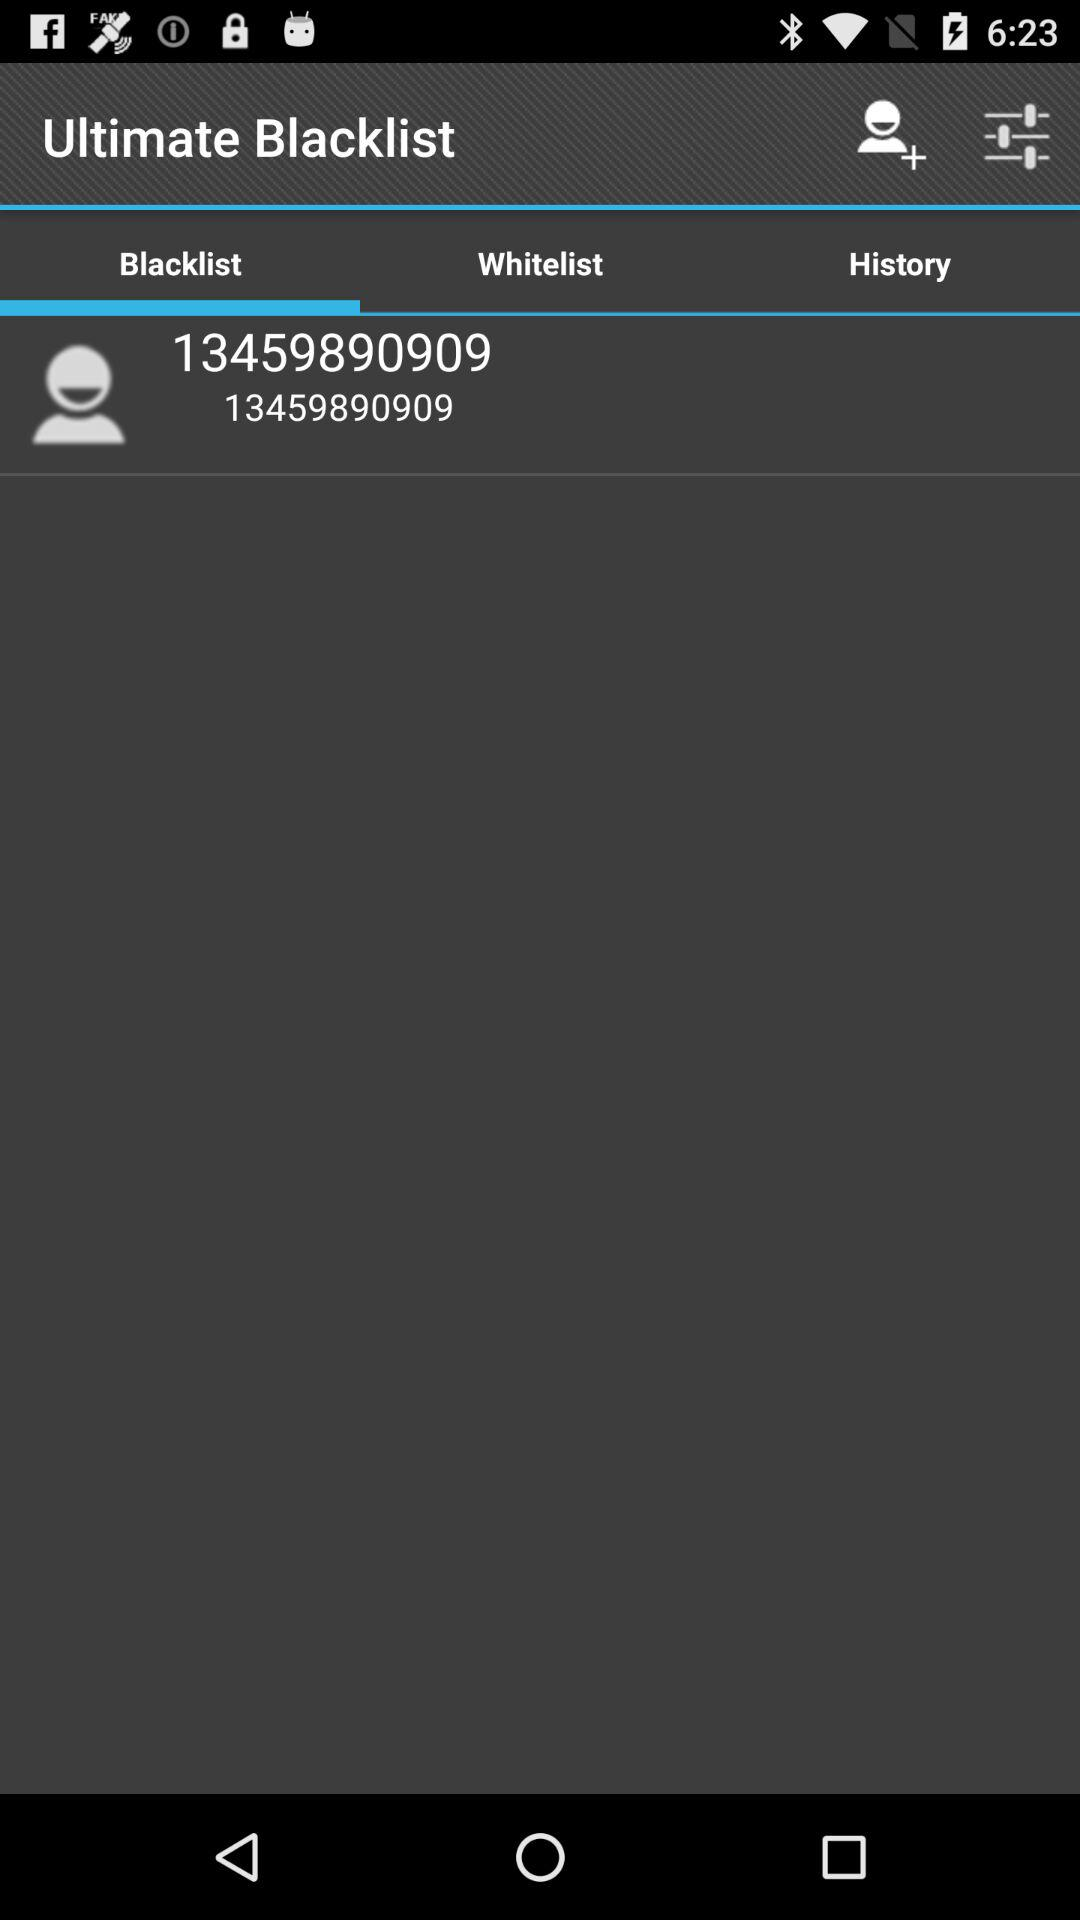What number is on the blacklist? The number on the blacklist is 13459890909. 